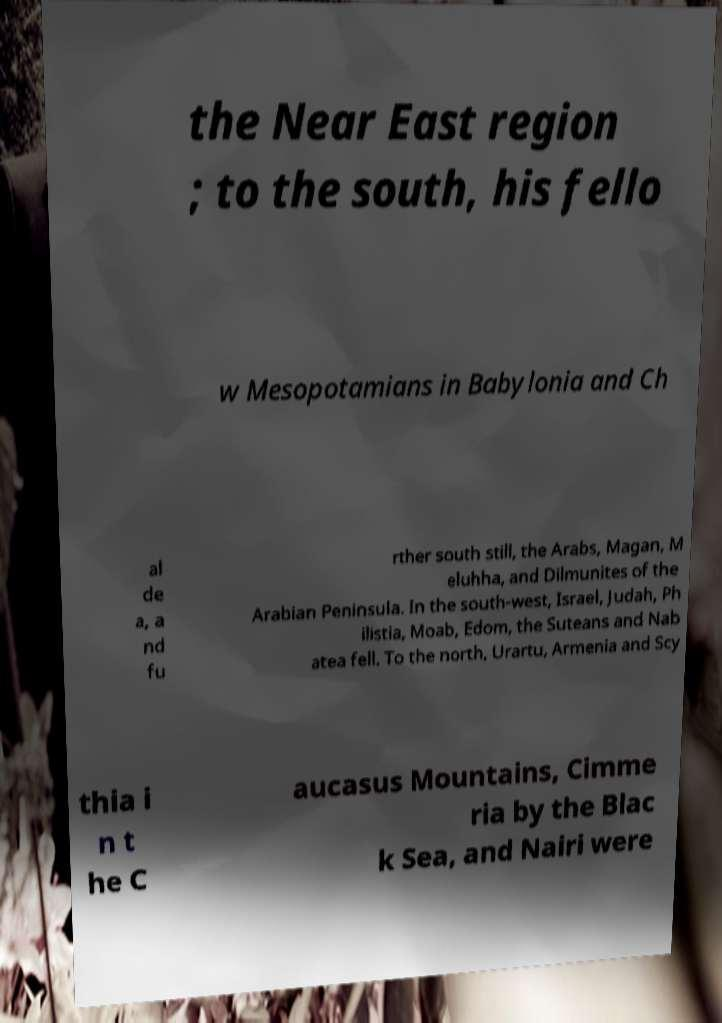Could you assist in decoding the text presented in this image and type it out clearly? the Near East region ; to the south, his fello w Mesopotamians in Babylonia and Ch al de a, a nd fu rther south still, the Arabs, Magan, M eluhha, and Dilmunites of the Arabian Peninsula. In the south-west, Israel, Judah, Ph ilistia, Moab, Edom, the Suteans and Nab atea fell. To the north, Urartu, Armenia and Scy thia i n t he C aucasus Mountains, Cimme ria by the Blac k Sea, and Nairi were 